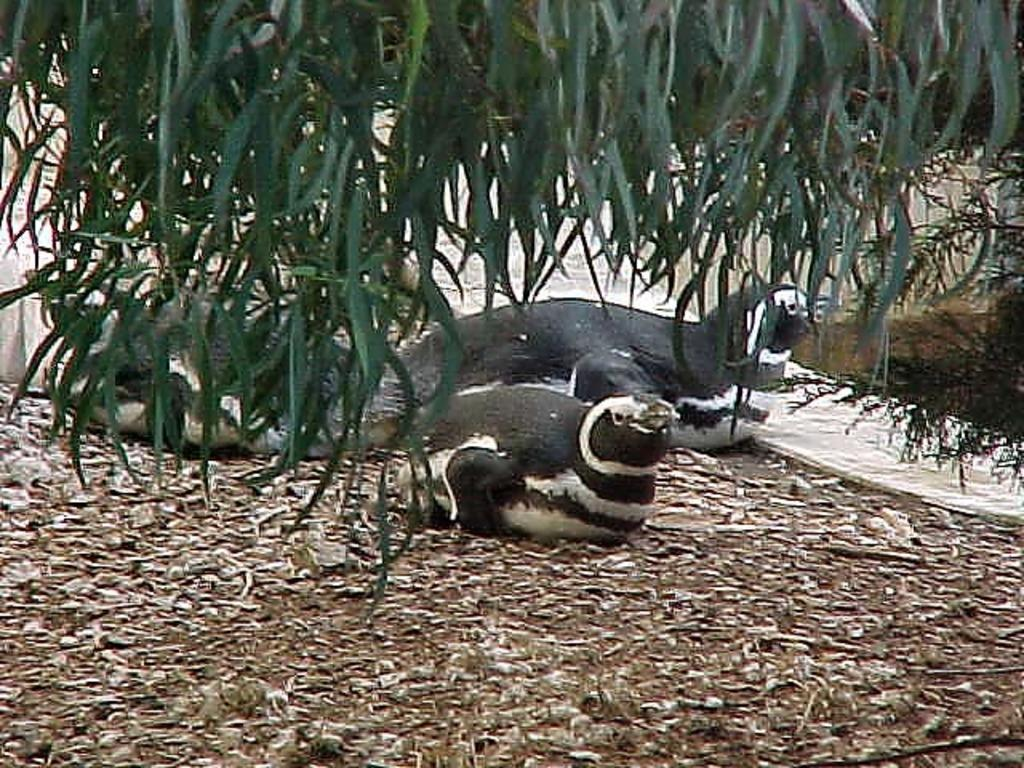What type of animals are in the image? There are seals in the image. What is located in the front of the image? There is a tree in the front of the image. What can be seen at the bottom of the image? There are leaves visible at the bottom of the image. What type of neck accessory is visible on the seals in the image? There is no neck accessory visible on the seals in the image, as seals do not typically wear such items. 